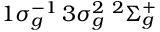Convert formula to latex. <formula><loc_0><loc_0><loc_500><loc_500>1 \sigma _ { g } ^ { - 1 } \, 3 \sigma _ { g } ^ { 2 } \, ^ { 2 } \Sigma _ { g } ^ { + }</formula> 